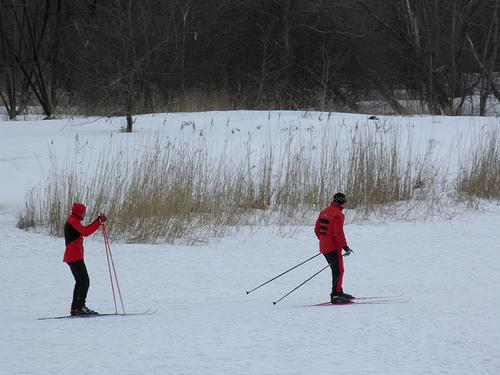Question: what are the people doing?
Choices:
A. Skiing.
B. Snowboarding.
C. Skating.
D. Bobsledding.
Answer with the letter. Answer: A Question: who is skiing?
Choices:
A. The people.
B. The tourists.
C. Schoolchildren.
D. Ski class.
Answer with the letter. Answer: A Question: why are the people wearing coats?
Choices:
A. It's windy.
B. It is cold.
C. To protect from the sun.
D. To block the rain.
Answer with the letter. Answer: B Question: what color are the coats?
Choices:
A. Teal.
B. Purple.
C. Red.
D. Tangerine.
Answer with the letter. Answer: C Question: what is on the ground?
Choices:
A. Slush.
B. Sleet.
C. Hail.
D. Snow.
Answer with the letter. Answer: D Question: where are the people?
Choices:
A. In the snow.
B. On the water.
C. On the boat.
D. In a field.
Answer with the letter. Answer: A Question: when is it?
Choices:
A. Nighttime.
B. Dinner time.
C. Day time.
D. Early morning.
Answer with the letter. Answer: C 